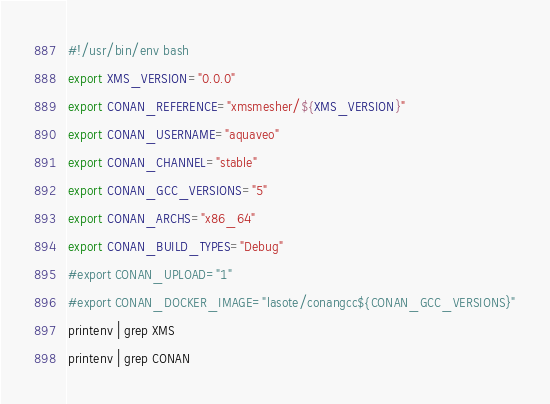<code> <loc_0><loc_0><loc_500><loc_500><_Bash_>#!/usr/bin/env bash
export XMS_VERSION="0.0.0"
export CONAN_REFERENCE="xmsmesher/${XMS_VERSION}"
export CONAN_USERNAME="aquaveo"
export CONAN_CHANNEL="stable"
export CONAN_GCC_VERSIONS="5"
export CONAN_ARCHS="x86_64"
export CONAN_BUILD_TYPES="Debug"
#export CONAN_UPLOAD="1"
#export CONAN_DOCKER_IMAGE="lasote/conangcc${CONAN_GCC_VERSIONS}"
printenv | grep XMS
printenv | grep CONAN
</code> 